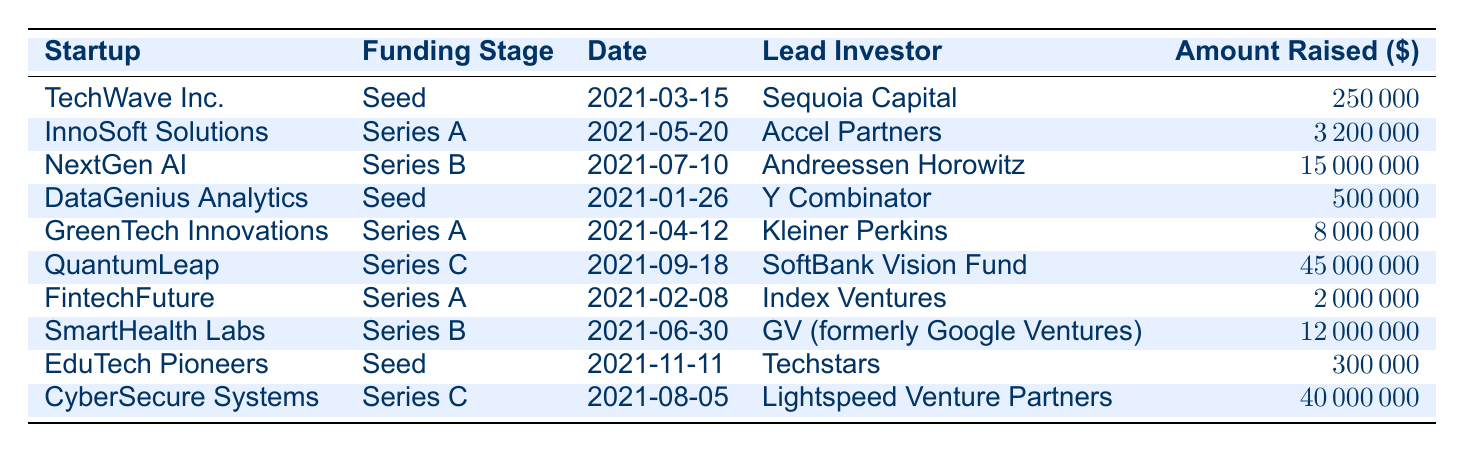What was the total amount raised by startups in Series A funding rounds? To find the total amount raised by Series A startups, we need to look at each Series A entry: InnoSoft Solutions raised 3,200,000, GreenTech Innovations raised 8,000,000, and FintechFuture raised 2,000,000. Adding these gives us 3,200,000 + 8,000,000 + 2,000,000 = 13,200,000.
Answer: 13,200,000 Which startup had the highest amount raised in 2021? By comparing the amounts raised for each startup, QuantumLeap raised 45,000,000, which is greater than any other amounts listed. The next highest is CyberSecure Systems at 40,000,000. Thus, QuantumLeap holds the highest funding.
Answer: QuantumLeap Did any startups raise more than 10 million dollars? Checking the amounts raised, we see that NextGen AI (15,000,000), QuantumLeap (45,000,000), SmartHealth Labs (12,000,000), and CyberSecure Systems (40,000,000) raised more than 10 million. Thus, the answer is yes.
Answer: Yes What is the average amount raised across all funding rounds? To calculate the average, we sum all the amounts raised: 250,000 + 3,200,000 + 15,000,000 + 500,000 + 8,000,000 + 45,000,000 + 2,000,000 + 12,000,000 + 300,000 + 40,000,000 = 126,250,000. There are 10 funding rounds, so the average is 126,250,000 / 10 = 12,625,000.
Answer: 12,625,000 Is Y Combinator the lead investor for more than one startup? Checking the table, Y Combinator is listed only once as the lead investor for DataGenius Analytics. Therefore, there are no other startups led by Y Combinator.
Answer: No Which funding stage had the most startups raising funds? By reviewing the table, we see three startups in Seed funding, three in Series A, two in Series B, and two in Series C. Thus, Seed and Series A are tied for the most at three each.
Answer: Seed and Series A How many months apart were the earliest and latest funding dates? The earliest funding date is DataGenius Analytics on January 26, 2021, and the latest is EduTech Pioneers on November 11, 2021. Counting the months: January to November is 10 months apart.
Answer: 10 months What are the funding rounds with amounts below 1 million? The amounts below 1 million include TechWave Inc. at 250,000, DataGenius Analytics at 500,000, and EduTech Pioneers at 300,000. These are the only ones listed.
Answer: 3 funding rounds below 1 million Which lead investor was responsible for the largest single funding round amount? The largest funding round was QuantumLeap with 45,000,000, led by SoftBank Vision Fund, which is the highest recorded.
Answer: SoftBank Vision Fund 